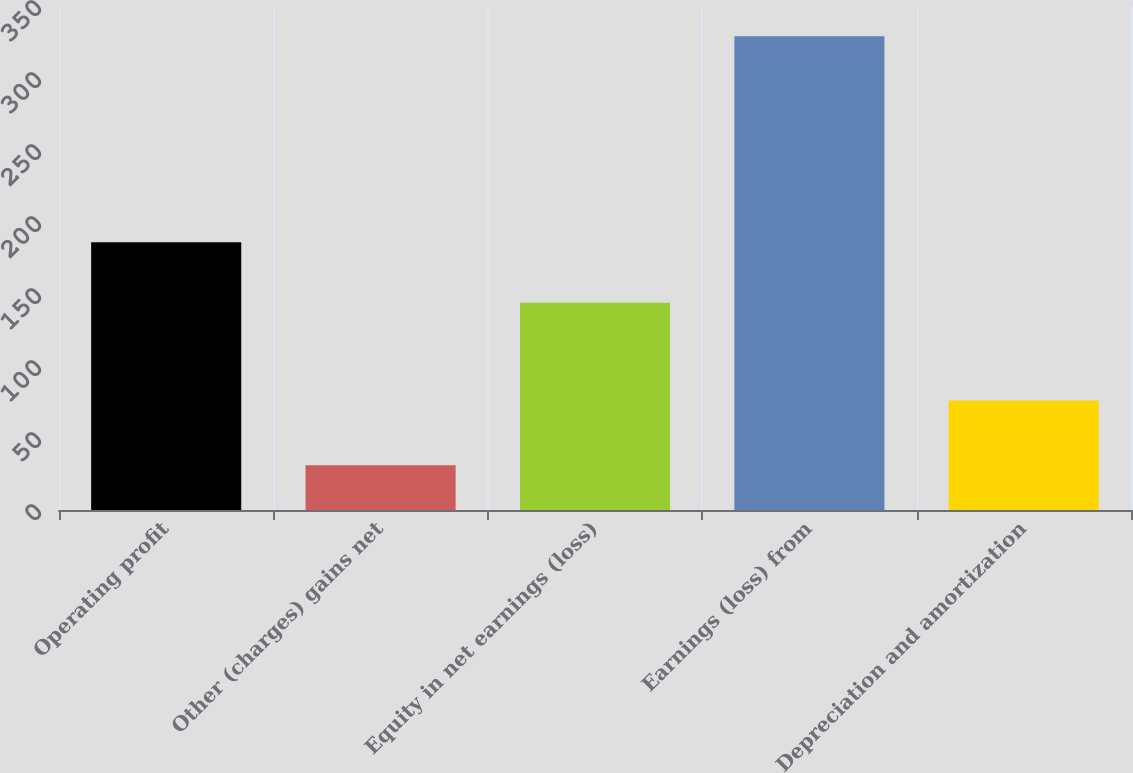Convert chart to OTSL. <chart><loc_0><loc_0><loc_500><loc_500><bar_chart><fcel>Operating profit<fcel>Other (charges) gains net<fcel>Equity in net earnings (loss)<fcel>Earnings (loss) from<fcel>Depreciation and amortization<nl><fcel>186<fcel>31<fcel>144<fcel>329<fcel>76<nl></chart> 